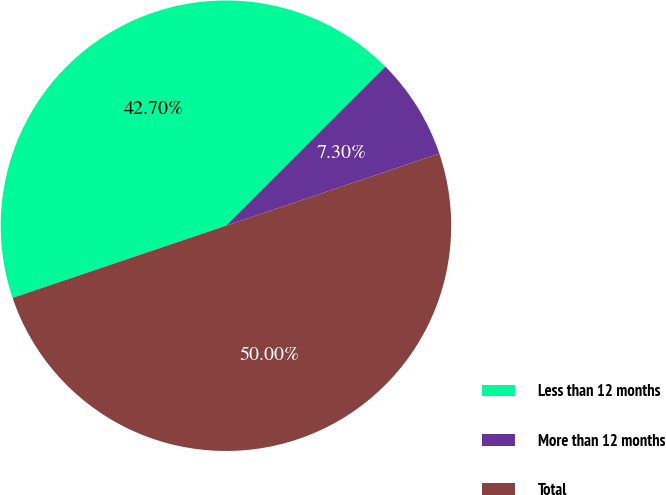Convert chart. <chart><loc_0><loc_0><loc_500><loc_500><pie_chart><fcel>Less than 12 months<fcel>More than 12 months<fcel>Total<nl><fcel>42.7%<fcel>7.3%<fcel>50.0%<nl></chart> 